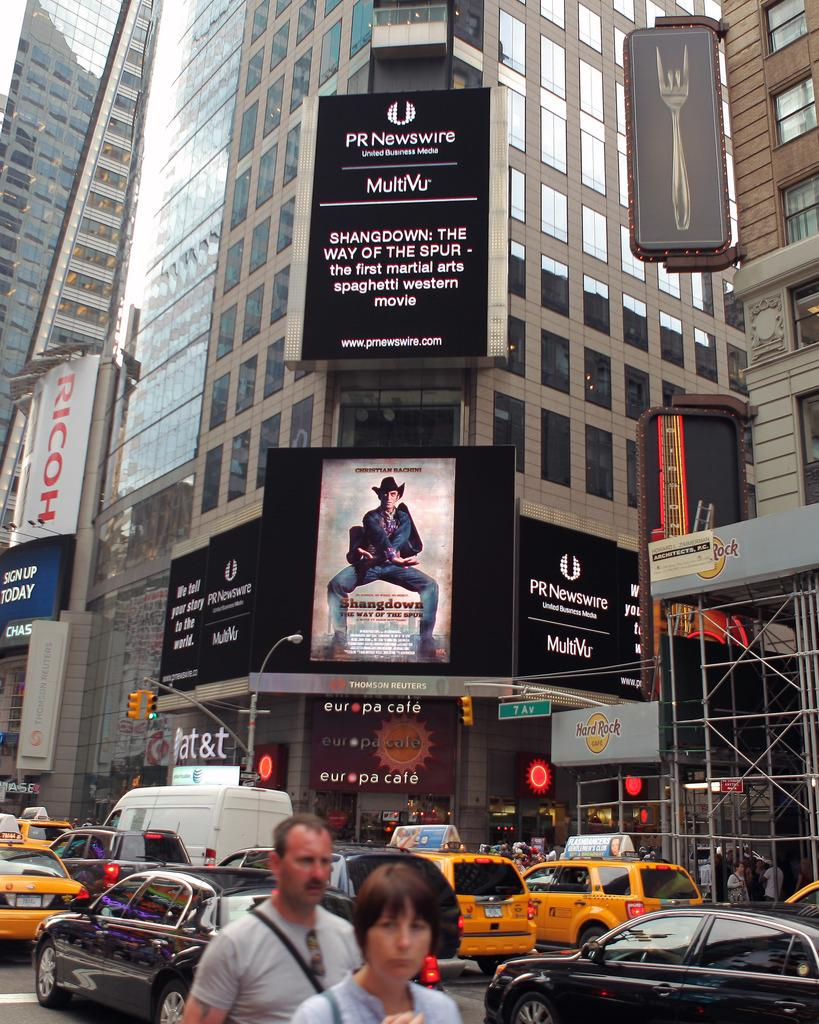<image>
Render a clear and concise summary of the photo. A billboard for PR Newswire hangs over a picture of a man in a cowboy hat. 